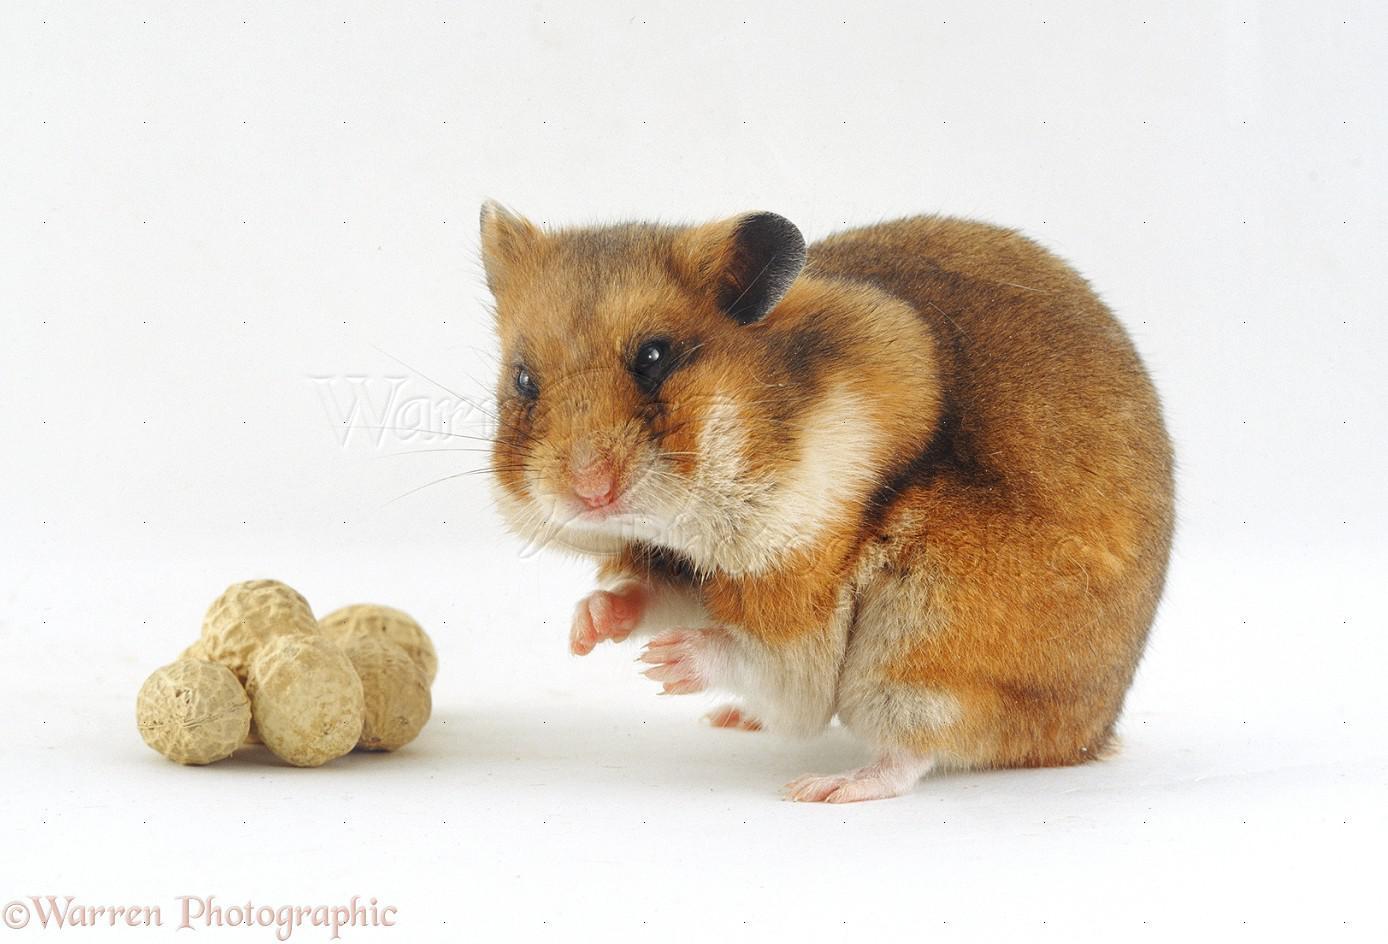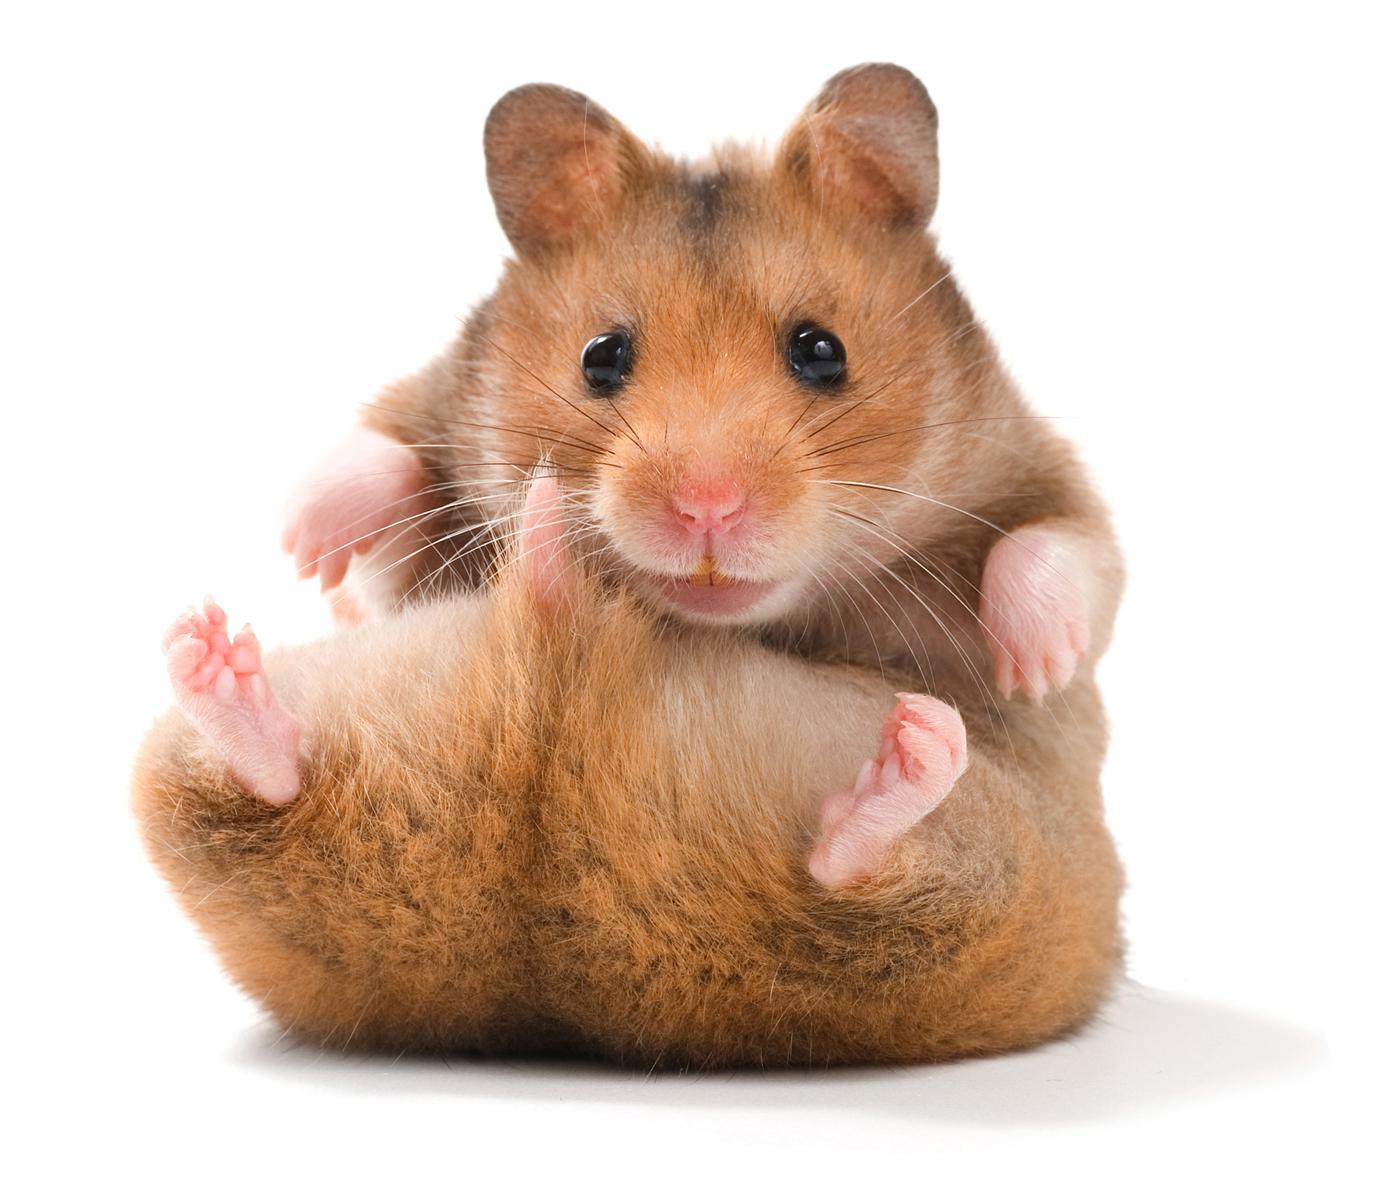The first image is the image on the left, the second image is the image on the right. Evaluate the accuracy of this statement regarding the images: "In at least one of the images, a small creature is interacting with a round object and the entire round object is visible.". Is it true? Answer yes or no. Yes. The first image is the image on the left, the second image is the image on the right. Considering the images on both sides, is "Each image contains exactly one pet rodent, and one of the animals poses bent forward with front paws off the ground and hind feet flat on the ground." valid? Answer yes or no. Yes. 